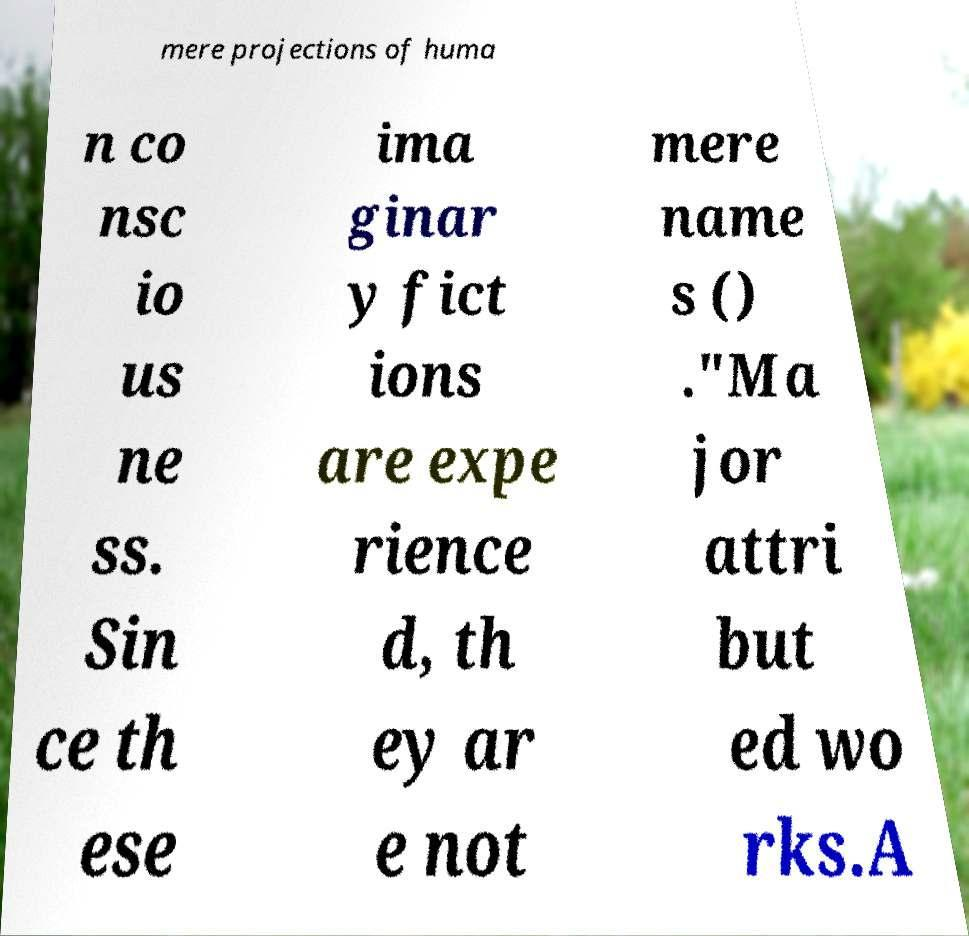Can you accurately transcribe the text from the provided image for me? mere projections of huma n co nsc io us ne ss. Sin ce th ese ima ginar y fict ions are expe rience d, th ey ar e not mere name s () ."Ma jor attri but ed wo rks.A 